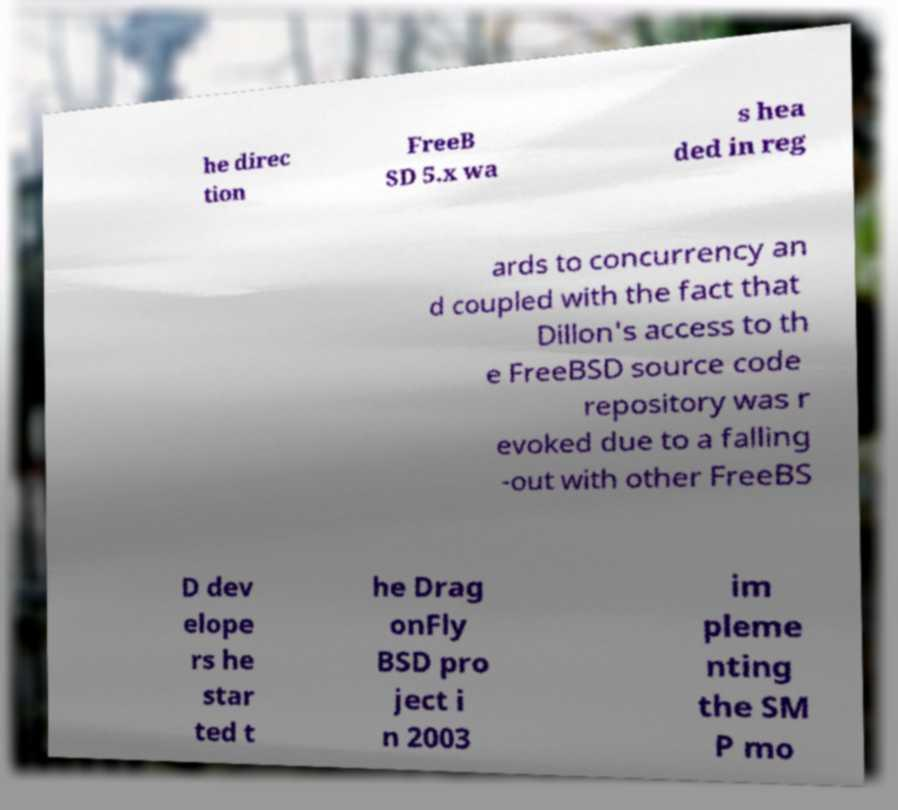Could you extract and type out the text from this image? he direc tion FreeB SD 5.x wa s hea ded in reg ards to concurrency an d coupled with the fact that Dillon's access to th e FreeBSD source code repository was r evoked due to a falling -out with other FreeBS D dev elope rs he star ted t he Drag onFly BSD pro ject i n 2003 im pleme nting the SM P mo 